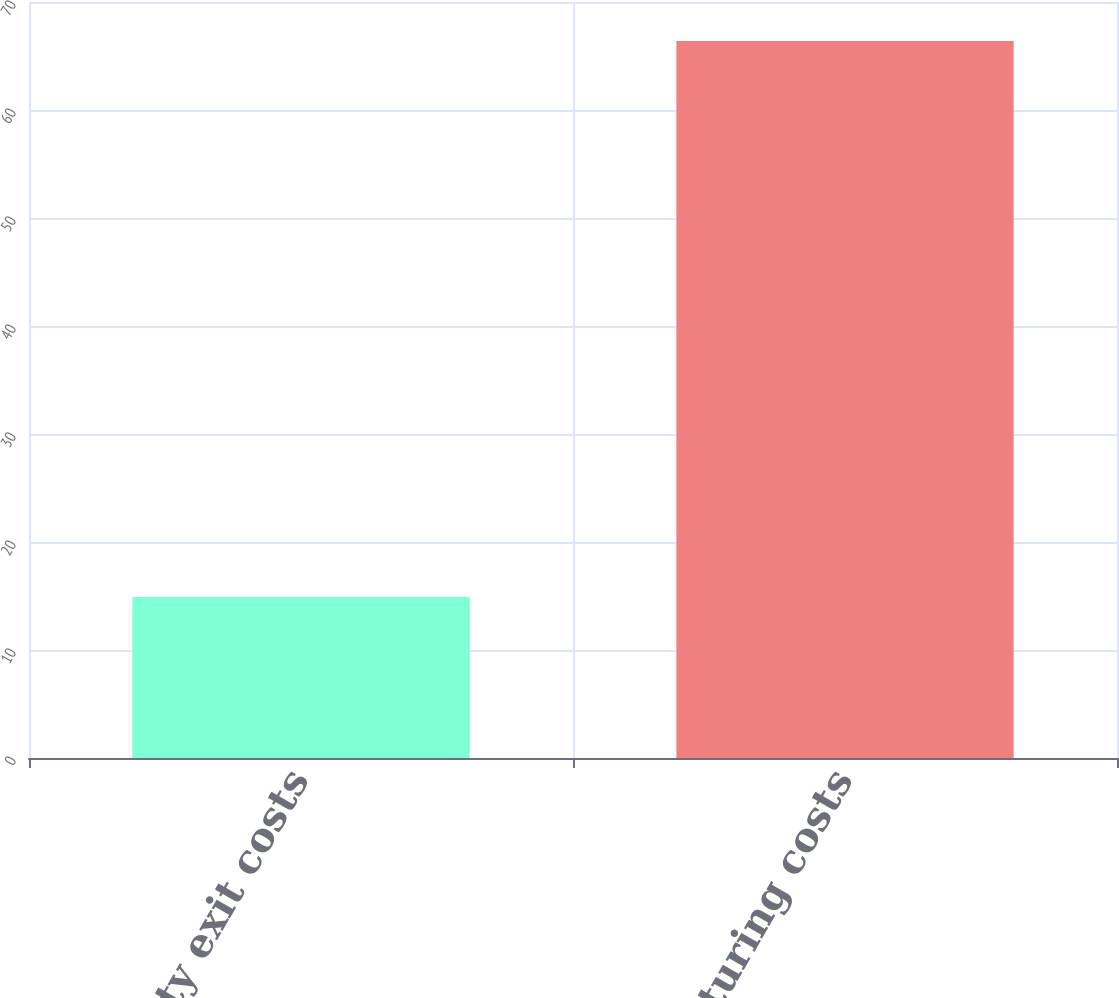Convert chart. <chart><loc_0><loc_0><loc_500><loc_500><bar_chart><fcel>Facility exit costs<fcel>Restructuring costs<nl><fcel>14.9<fcel>66.4<nl></chart> 